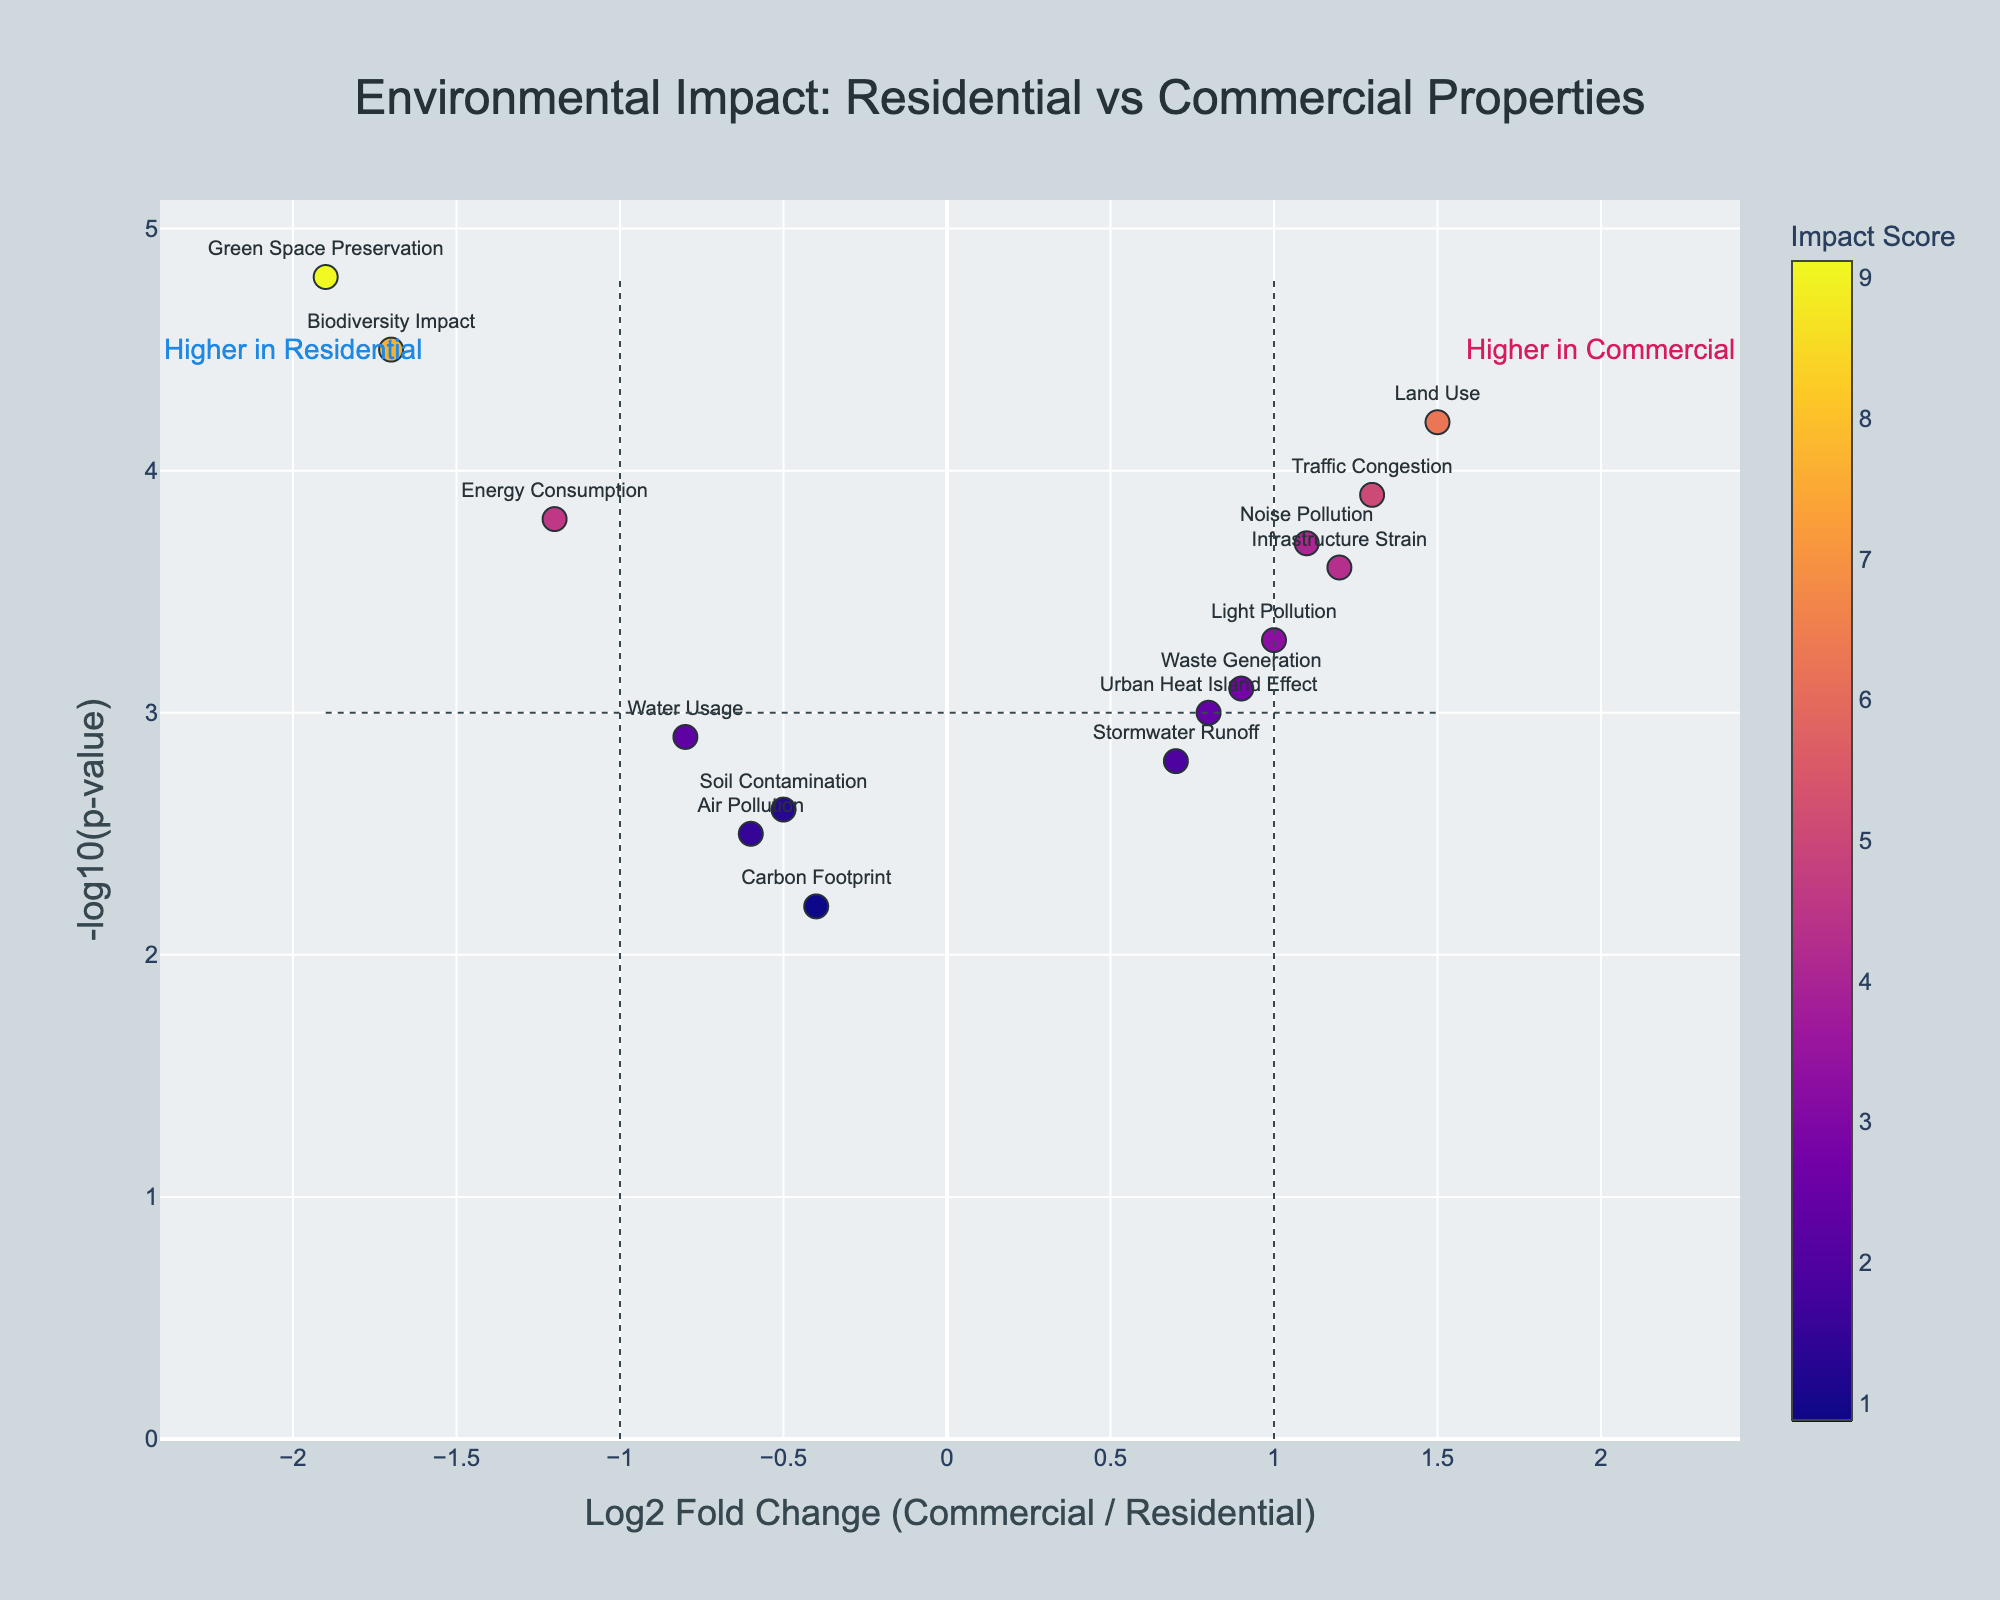How many environmental factors are shown in the plot? Count the number of distinct data points labeled with environmental factors.
Answer: 15 Which environmental factor has the highest negative log p-value? Look at the y-axis values and identify the highest point, which represents the highest negative log p-value. The factor label at that point is the answer.
Answer: Green Space Preservation Which factor shows the highest positive log2 fold change? Find the environmental factor on the x-axis with the highest positive value.
Answer: Land Use What is the environmental impact on Energy Consumption and Carbon Footprint compared to each other? Compare the log2 fold changes and negative log p-values for Energy Consumption and Carbon Footprint. Energy Consumption has a log2 fold change of -1.2 and a negative log p-value of 3.8, while Carbon Footprint has a log2 fold change of -0.4 and a negative log p-value of 2.2. Both are negatively correlated with commercial properties but Energy Consumption shows a higher negative impact.
Answer: Energy Consumption has a higher negative impact Which factors show a log2 fold change greater than 1? Look for factors on the plot with log2 fold change values (x-axis) greater than 1. They include Infrastructure Strain, Traffic Congestion, Noise Pollution, and Land Use.
Answer: Infrastructure Strain, Traffic Congestion, Noise Pollution, Land Use Are there more factors with positive or negative log2 fold change? Count the number of factors with positive log2 fold change and compare it to those with negative log2 fold change. There are 7 factors (Traffic Congestion, Stormwater Runoff, Urban Heat Island Effect, Infrastructure Strain, Light Pollution, Noise Pollution, and Land Use) with positive log2 fold change, and 8 factors (Biodiversity Impact, Energy Consumption, Green Space Preservation, Soil Contamination, Air Pollution, Carbon Footprint, Waste Generation, and Water Usage) with negative log2 fold change.
Answer: More factors have negative log2 fold change What does the quadrant with high log2 fold change and high negative log p-value represent? Identify the upper right quadrant of the plot, which shows factors with both high log2 fold change and high negative log p-value. This represents factors that are significantly higher in commercial properties, suggesting a stronger environmental impact when compared to residential properties.
Answer: Higher impact in commercial properties Which environmental factor has the lowest impact (lowest log2 fold change and negative log p-value)? Identify the factor with the smallest negative log2 fold change and lowest negative log p-value by locating the data point closest to the origin (0, 0) on both axes. This factor is Carbon Footprint with log2 fold change of -0.4 and negative log p-value of 2.2.
Answer: Carbon Footprint What do the threshold lines represent on the plot? The vertical threshold lines at log2 fold change of 1 and -1 indicate significant changes in environmental impact between commercial and residential properties. The horizontal threshold line at negative log p-value of 3 highlights statistical significance. Points beyond these lines suggest significant impact and statistical reliability.
Answer: Significance thresholds 